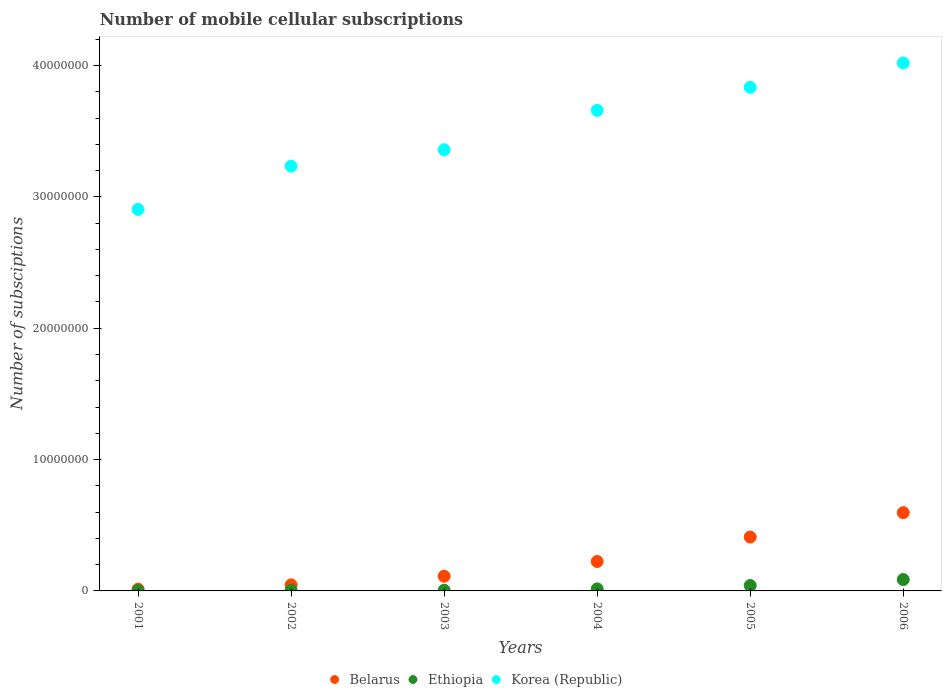Is the number of dotlines equal to the number of legend labels?
Your answer should be very brief. Yes. What is the number of mobile cellular subscriptions in Ethiopia in 2002?
Offer a terse response. 5.04e+04. Across all years, what is the maximum number of mobile cellular subscriptions in Korea (Republic)?
Provide a succinct answer. 4.02e+07. Across all years, what is the minimum number of mobile cellular subscriptions in Ethiopia?
Make the answer very short. 2.75e+04. In which year was the number of mobile cellular subscriptions in Ethiopia maximum?
Offer a terse response. 2006. In which year was the number of mobile cellular subscriptions in Korea (Republic) minimum?
Your response must be concise. 2001. What is the total number of mobile cellular subscriptions in Ethiopia in the graph?
Provide a succinct answer. 1.56e+06. What is the difference between the number of mobile cellular subscriptions in Belarus in 2003 and that in 2005?
Offer a very short reply. -2.98e+06. What is the difference between the number of mobile cellular subscriptions in Belarus in 2003 and the number of mobile cellular subscriptions in Korea (Republic) in 2001?
Offer a terse response. -2.79e+07. What is the average number of mobile cellular subscriptions in Korea (Republic) per year?
Offer a very short reply. 3.50e+07. In the year 2002, what is the difference between the number of mobile cellular subscriptions in Korea (Republic) and number of mobile cellular subscriptions in Belarus?
Give a very brief answer. 3.19e+07. What is the ratio of the number of mobile cellular subscriptions in Ethiopia in 2004 to that in 2006?
Keep it short and to the point. 0.18. Is the number of mobile cellular subscriptions in Korea (Republic) in 2001 less than that in 2006?
Your response must be concise. Yes. Is the difference between the number of mobile cellular subscriptions in Korea (Republic) in 2003 and 2005 greater than the difference between the number of mobile cellular subscriptions in Belarus in 2003 and 2005?
Offer a very short reply. No. What is the difference between the highest and the second highest number of mobile cellular subscriptions in Korea (Republic)?
Give a very brief answer. 1.85e+06. What is the difference between the highest and the lowest number of mobile cellular subscriptions in Ethiopia?
Make the answer very short. 8.39e+05. In how many years, is the number of mobile cellular subscriptions in Ethiopia greater than the average number of mobile cellular subscriptions in Ethiopia taken over all years?
Keep it short and to the point. 2. Is the sum of the number of mobile cellular subscriptions in Korea (Republic) in 2001 and 2002 greater than the maximum number of mobile cellular subscriptions in Belarus across all years?
Ensure brevity in your answer.  Yes. Does the number of mobile cellular subscriptions in Korea (Republic) monotonically increase over the years?
Keep it short and to the point. Yes. How many dotlines are there?
Offer a very short reply. 3. How many years are there in the graph?
Provide a succinct answer. 6. Are the values on the major ticks of Y-axis written in scientific E-notation?
Provide a succinct answer. No. Does the graph contain any zero values?
Make the answer very short. No. Does the graph contain grids?
Give a very brief answer. No. How many legend labels are there?
Offer a terse response. 3. How are the legend labels stacked?
Keep it short and to the point. Horizontal. What is the title of the graph?
Provide a succinct answer. Number of mobile cellular subscriptions. Does "Sint Maarten (Dutch part)" appear as one of the legend labels in the graph?
Provide a succinct answer. No. What is the label or title of the Y-axis?
Offer a terse response. Number of subsciptions. What is the Number of subsciptions in Belarus in 2001?
Ensure brevity in your answer.  1.38e+05. What is the Number of subsciptions of Ethiopia in 2001?
Make the answer very short. 2.75e+04. What is the Number of subsciptions in Korea (Republic) in 2001?
Provide a succinct answer. 2.90e+07. What is the Number of subsciptions of Belarus in 2002?
Make the answer very short. 4.63e+05. What is the Number of subsciptions of Ethiopia in 2002?
Your response must be concise. 5.04e+04. What is the Number of subsciptions in Korea (Republic) in 2002?
Your answer should be compact. 3.23e+07. What is the Number of subsciptions in Belarus in 2003?
Provide a short and direct response. 1.12e+06. What is the Number of subsciptions in Ethiopia in 2003?
Your answer should be very brief. 5.13e+04. What is the Number of subsciptions in Korea (Republic) in 2003?
Offer a terse response. 3.36e+07. What is the Number of subsciptions of Belarus in 2004?
Your answer should be compact. 2.24e+06. What is the Number of subsciptions in Ethiopia in 2004?
Make the answer very short. 1.56e+05. What is the Number of subsciptions of Korea (Republic) in 2004?
Your answer should be very brief. 3.66e+07. What is the Number of subsciptions of Belarus in 2005?
Your response must be concise. 4.10e+06. What is the Number of subsciptions of Ethiopia in 2005?
Provide a succinct answer. 4.11e+05. What is the Number of subsciptions of Korea (Republic) in 2005?
Offer a terse response. 3.83e+07. What is the Number of subsciptions in Belarus in 2006?
Offer a very short reply. 5.96e+06. What is the Number of subsciptions in Ethiopia in 2006?
Offer a very short reply. 8.67e+05. What is the Number of subsciptions of Korea (Republic) in 2006?
Make the answer very short. 4.02e+07. Across all years, what is the maximum Number of subsciptions of Belarus?
Keep it short and to the point. 5.96e+06. Across all years, what is the maximum Number of subsciptions of Ethiopia?
Make the answer very short. 8.67e+05. Across all years, what is the maximum Number of subsciptions of Korea (Republic)?
Ensure brevity in your answer.  4.02e+07. Across all years, what is the minimum Number of subsciptions in Belarus?
Make the answer very short. 1.38e+05. Across all years, what is the minimum Number of subsciptions of Ethiopia?
Offer a terse response. 2.75e+04. Across all years, what is the minimum Number of subsciptions in Korea (Republic)?
Make the answer very short. 2.90e+07. What is the total Number of subsciptions of Belarus in the graph?
Offer a terse response. 1.40e+07. What is the total Number of subsciptions in Ethiopia in the graph?
Offer a terse response. 1.56e+06. What is the total Number of subsciptions in Korea (Republic) in the graph?
Offer a very short reply. 2.10e+08. What is the difference between the Number of subsciptions in Belarus in 2001 and that in 2002?
Ensure brevity in your answer.  -3.24e+05. What is the difference between the Number of subsciptions in Ethiopia in 2001 and that in 2002?
Your response must be concise. -2.29e+04. What is the difference between the Number of subsciptions in Korea (Republic) in 2001 and that in 2002?
Ensure brevity in your answer.  -3.30e+06. What is the difference between the Number of subsciptions of Belarus in 2001 and that in 2003?
Provide a short and direct response. -9.80e+05. What is the difference between the Number of subsciptions in Ethiopia in 2001 and that in 2003?
Offer a very short reply. -2.38e+04. What is the difference between the Number of subsciptions of Korea (Republic) in 2001 and that in 2003?
Provide a succinct answer. -4.55e+06. What is the difference between the Number of subsciptions of Belarus in 2001 and that in 2004?
Your answer should be very brief. -2.10e+06. What is the difference between the Number of subsciptions of Ethiopia in 2001 and that in 2004?
Your answer should be very brief. -1.28e+05. What is the difference between the Number of subsciptions of Korea (Republic) in 2001 and that in 2004?
Your response must be concise. -7.54e+06. What is the difference between the Number of subsciptions of Belarus in 2001 and that in 2005?
Your answer should be very brief. -3.96e+06. What is the difference between the Number of subsciptions in Ethiopia in 2001 and that in 2005?
Provide a short and direct response. -3.83e+05. What is the difference between the Number of subsciptions in Korea (Republic) in 2001 and that in 2005?
Keep it short and to the point. -9.30e+06. What is the difference between the Number of subsciptions of Belarus in 2001 and that in 2006?
Provide a succinct answer. -5.82e+06. What is the difference between the Number of subsciptions of Ethiopia in 2001 and that in 2006?
Provide a succinct answer. -8.39e+05. What is the difference between the Number of subsciptions in Korea (Republic) in 2001 and that in 2006?
Ensure brevity in your answer.  -1.12e+07. What is the difference between the Number of subsciptions of Belarus in 2002 and that in 2003?
Offer a very short reply. -6.55e+05. What is the difference between the Number of subsciptions of Ethiopia in 2002 and that in 2003?
Provide a short and direct response. -955. What is the difference between the Number of subsciptions of Korea (Republic) in 2002 and that in 2003?
Your response must be concise. -1.25e+06. What is the difference between the Number of subsciptions of Belarus in 2002 and that in 2004?
Your answer should be compact. -1.78e+06. What is the difference between the Number of subsciptions of Ethiopia in 2002 and that in 2004?
Keep it short and to the point. -1.05e+05. What is the difference between the Number of subsciptions of Korea (Republic) in 2002 and that in 2004?
Provide a succinct answer. -4.24e+06. What is the difference between the Number of subsciptions of Belarus in 2002 and that in 2005?
Offer a very short reply. -3.64e+06. What is the difference between the Number of subsciptions of Ethiopia in 2002 and that in 2005?
Your answer should be very brief. -3.60e+05. What is the difference between the Number of subsciptions of Korea (Republic) in 2002 and that in 2005?
Offer a very short reply. -6.00e+06. What is the difference between the Number of subsciptions in Belarus in 2002 and that in 2006?
Your response must be concise. -5.50e+06. What is the difference between the Number of subsciptions of Ethiopia in 2002 and that in 2006?
Your answer should be compact. -8.16e+05. What is the difference between the Number of subsciptions of Korea (Republic) in 2002 and that in 2006?
Provide a succinct answer. -7.85e+06. What is the difference between the Number of subsciptions of Belarus in 2003 and that in 2004?
Your response must be concise. -1.12e+06. What is the difference between the Number of subsciptions in Ethiopia in 2003 and that in 2004?
Your answer should be compact. -1.04e+05. What is the difference between the Number of subsciptions in Korea (Republic) in 2003 and that in 2004?
Keep it short and to the point. -2.99e+06. What is the difference between the Number of subsciptions of Belarus in 2003 and that in 2005?
Your response must be concise. -2.98e+06. What is the difference between the Number of subsciptions of Ethiopia in 2003 and that in 2005?
Provide a short and direct response. -3.59e+05. What is the difference between the Number of subsciptions of Korea (Republic) in 2003 and that in 2005?
Your answer should be compact. -4.75e+06. What is the difference between the Number of subsciptions of Belarus in 2003 and that in 2006?
Keep it short and to the point. -4.84e+06. What is the difference between the Number of subsciptions of Ethiopia in 2003 and that in 2006?
Ensure brevity in your answer.  -8.15e+05. What is the difference between the Number of subsciptions of Korea (Republic) in 2003 and that in 2006?
Keep it short and to the point. -6.61e+06. What is the difference between the Number of subsciptions in Belarus in 2004 and that in 2005?
Your answer should be compact. -1.86e+06. What is the difference between the Number of subsciptions in Ethiopia in 2004 and that in 2005?
Make the answer very short. -2.55e+05. What is the difference between the Number of subsciptions of Korea (Republic) in 2004 and that in 2005?
Make the answer very short. -1.76e+06. What is the difference between the Number of subsciptions in Belarus in 2004 and that in 2006?
Your answer should be compact. -3.72e+06. What is the difference between the Number of subsciptions in Ethiopia in 2004 and that in 2006?
Provide a succinct answer. -7.11e+05. What is the difference between the Number of subsciptions in Korea (Republic) in 2004 and that in 2006?
Provide a short and direct response. -3.61e+06. What is the difference between the Number of subsciptions of Belarus in 2005 and that in 2006?
Your answer should be compact. -1.86e+06. What is the difference between the Number of subsciptions of Ethiopia in 2005 and that in 2006?
Your answer should be very brief. -4.56e+05. What is the difference between the Number of subsciptions in Korea (Republic) in 2005 and that in 2006?
Your answer should be very brief. -1.85e+06. What is the difference between the Number of subsciptions of Belarus in 2001 and the Number of subsciptions of Ethiopia in 2002?
Your answer should be compact. 8.80e+04. What is the difference between the Number of subsciptions in Belarus in 2001 and the Number of subsciptions in Korea (Republic) in 2002?
Your response must be concise. -3.22e+07. What is the difference between the Number of subsciptions in Ethiopia in 2001 and the Number of subsciptions in Korea (Republic) in 2002?
Make the answer very short. -3.23e+07. What is the difference between the Number of subsciptions of Belarus in 2001 and the Number of subsciptions of Ethiopia in 2003?
Offer a terse response. 8.70e+04. What is the difference between the Number of subsciptions of Belarus in 2001 and the Number of subsciptions of Korea (Republic) in 2003?
Make the answer very short. -3.35e+07. What is the difference between the Number of subsciptions of Ethiopia in 2001 and the Number of subsciptions of Korea (Republic) in 2003?
Keep it short and to the point. -3.36e+07. What is the difference between the Number of subsciptions of Belarus in 2001 and the Number of subsciptions of Ethiopia in 2004?
Ensure brevity in your answer.  -1.72e+04. What is the difference between the Number of subsciptions in Belarus in 2001 and the Number of subsciptions in Korea (Republic) in 2004?
Provide a short and direct response. -3.64e+07. What is the difference between the Number of subsciptions of Ethiopia in 2001 and the Number of subsciptions of Korea (Republic) in 2004?
Your response must be concise. -3.66e+07. What is the difference between the Number of subsciptions of Belarus in 2001 and the Number of subsciptions of Ethiopia in 2005?
Provide a short and direct response. -2.72e+05. What is the difference between the Number of subsciptions in Belarus in 2001 and the Number of subsciptions in Korea (Republic) in 2005?
Make the answer very short. -3.82e+07. What is the difference between the Number of subsciptions in Ethiopia in 2001 and the Number of subsciptions in Korea (Republic) in 2005?
Keep it short and to the point. -3.83e+07. What is the difference between the Number of subsciptions of Belarus in 2001 and the Number of subsciptions of Ethiopia in 2006?
Make the answer very short. -7.28e+05. What is the difference between the Number of subsciptions of Belarus in 2001 and the Number of subsciptions of Korea (Republic) in 2006?
Offer a terse response. -4.01e+07. What is the difference between the Number of subsciptions of Ethiopia in 2001 and the Number of subsciptions of Korea (Republic) in 2006?
Make the answer very short. -4.02e+07. What is the difference between the Number of subsciptions in Belarus in 2002 and the Number of subsciptions in Ethiopia in 2003?
Offer a terse response. 4.11e+05. What is the difference between the Number of subsciptions of Belarus in 2002 and the Number of subsciptions of Korea (Republic) in 2003?
Offer a very short reply. -3.31e+07. What is the difference between the Number of subsciptions in Ethiopia in 2002 and the Number of subsciptions in Korea (Republic) in 2003?
Your answer should be very brief. -3.35e+07. What is the difference between the Number of subsciptions of Belarus in 2002 and the Number of subsciptions of Ethiopia in 2004?
Your answer should be compact. 3.07e+05. What is the difference between the Number of subsciptions of Belarus in 2002 and the Number of subsciptions of Korea (Republic) in 2004?
Give a very brief answer. -3.61e+07. What is the difference between the Number of subsciptions in Ethiopia in 2002 and the Number of subsciptions in Korea (Republic) in 2004?
Give a very brief answer. -3.65e+07. What is the difference between the Number of subsciptions of Belarus in 2002 and the Number of subsciptions of Ethiopia in 2005?
Offer a terse response. 5.20e+04. What is the difference between the Number of subsciptions in Belarus in 2002 and the Number of subsciptions in Korea (Republic) in 2005?
Your response must be concise. -3.79e+07. What is the difference between the Number of subsciptions of Ethiopia in 2002 and the Number of subsciptions of Korea (Republic) in 2005?
Offer a terse response. -3.83e+07. What is the difference between the Number of subsciptions in Belarus in 2002 and the Number of subsciptions in Ethiopia in 2006?
Provide a short and direct response. -4.04e+05. What is the difference between the Number of subsciptions of Belarus in 2002 and the Number of subsciptions of Korea (Republic) in 2006?
Offer a very short reply. -3.97e+07. What is the difference between the Number of subsciptions of Ethiopia in 2002 and the Number of subsciptions of Korea (Republic) in 2006?
Offer a very short reply. -4.01e+07. What is the difference between the Number of subsciptions of Belarus in 2003 and the Number of subsciptions of Ethiopia in 2004?
Your answer should be compact. 9.62e+05. What is the difference between the Number of subsciptions of Belarus in 2003 and the Number of subsciptions of Korea (Republic) in 2004?
Offer a very short reply. -3.55e+07. What is the difference between the Number of subsciptions of Ethiopia in 2003 and the Number of subsciptions of Korea (Republic) in 2004?
Ensure brevity in your answer.  -3.65e+07. What is the difference between the Number of subsciptions in Belarus in 2003 and the Number of subsciptions in Ethiopia in 2005?
Make the answer very short. 7.07e+05. What is the difference between the Number of subsciptions of Belarus in 2003 and the Number of subsciptions of Korea (Republic) in 2005?
Give a very brief answer. -3.72e+07. What is the difference between the Number of subsciptions in Ethiopia in 2003 and the Number of subsciptions in Korea (Republic) in 2005?
Make the answer very short. -3.83e+07. What is the difference between the Number of subsciptions in Belarus in 2003 and the Number of subsciptions in Ethiopia in 2006?
Your response must be concise. 2.51e+05. What is the difference between the Number of subsciptions of Belarus in 2003 and the Number of subsciptions of Korea (Republic) in 2006?
Provide a short and direct response. -3.91e+07. What is the difference between the Number of subsciptions of Ethiopia in 2003 and the Number of subsciptions of Korea (Republic) in 2006?
Offer a very short reply. -4.01e+07. What is the difference between the Number of subsciptions in Belarus in 2004 and the Number of subsciptions in Ethiopia in 2005?
Make the answer very short. 1.83e+06. What is the difference between the Number of subsciptions of Belarus in 2004 and the Number of subsciptions of Korea (Republic) in 2005?
Keep it short and to the point. -3.61e+07. What is the difference between the Number of subsciptions in Ethiopia in 2004 and the Number of subsciptions in Korea (Republic) in 2005?
Keep it short and to the point. -3.82e+07. What is the difference between the Number of subsciptions of Belarus in 2004 and the Number of subsciptions of Ethiopia in 2006?
Offer a terse response. 1.37e+06. What is the difference between the Number of subsciptions in Belarus in 2004 and the Number of subsciptions in Korea (Republic) in 2006?
Offer a very short reply. -3.80e+07. What is the difference between the Number of subsciptions of Ethiopia in 2004 and the Number of subsciptions of Korea (Republic) in 2006?
Your answer should be compact. -4.00e+07. What is the difference between the Number of subsciptions of Belarus in 2005 and the Number of subsciptions of Ethiopia in 2006?
Give a very brief answer. 3.23e+06. What is the difference between the Number of subsciptions of Belarus in 2005 and the Number of subsciptions of Korea (Republic) in 2006?
Give a very brief answer. -3.61e+07. What is the difference between the Number of subsciptions of Ethiopia in 2005 and the Number of subsciptions of Korea (Republic) in 2006?
Your answer should be compact. -3.98e+07. What is the average Number of subsciptions of Belarus per year?
Offer a very short reply. 2.34e+06. What is the average Number of subsciptions in Ethiopia per year?
Provide a succinct answer. 2.60e+05. What is the average Number of subsciptions of Korea (Republic) per year?
Offer a very short reply. 3.50e+07. In the year 2001, what is the difference between the Number of subsciptions of Belarus and Number of subsciptions of Ethiopia?
Offer a very short reply. 1.11e+05. In the year 2001, what is the difference between the Number of subsciptions in Belarus and Number of subsciptions in Korea (Republic)?
Offer a terse response. -2.89e+07. In the year 2001, what is the difference between the Number of subsciptions in Ethiopia and Number of subsciptions in Korea (Republic)?
Provide a short and direct response. -2.90e+07. In the year 2002, what is the difference between the Number of subsciptions of Belarus and Number of subsciptions of Ethiopia?
Offer a terse response. 4.12e+05. In the year 2002, what is the difference between the Number of subsciptions in Belarus and Number of subsciptions in Korea (Republic)?
Your response must be concise. -3.19e+07. In the year 2002, what is the difference between the Number of subsciptions of Ethiopia and Number of subsciptions of Korea (Republic)?
Give a very brief answer. -3.23e+07. In the year 2003, what is the difference between the Number of subsciptions in Belarus and Number of subsciptions in Ethiopia?
Provide a short and direct response. 1.07e+06. In the year 2003, what is the difference between the Number of subsciptions in Belarus and Number of subsciptions in Korea (Republic)?
Make the answer very short. -3.25e+07. In the year 2003, what is the difference between the Number of subsciptions in Ethiopia and Number of subsciptions in Korea (Republic)?
Make the answer very short. -3.35e+07. In the year 2004, what is the difference between the Number of subsciptions in Belarus and Number of subsciptions in Ethiopia?
Your answer should be very brief. 2.08e+06. In the year 2004, what is the difference between the Number of subsciptions of Belarus and Number of subsciptions of Korea (Republic)?
Provide a succinct answer. -3.43e+07. In the year 2004, what is the difference between the Number of subsciptions of Ethiopia and Number of subsciptions of Korea (Republic)?
Give a very brief answer. -3.64e+07. In the year 2005, what is the difference between the Number of subsciptions of Belarus and Number of subsciptions of Ethiopia?
Your answer should be compact. 3.69e+06. In the year 2005, what is the difference between the Number of subsciptions in Belarus and Number of subsciptions in Korea (Republic)?
Provide a short and direct response. -3.42e+07. In the year 2005, what is the difference between the Number of subsciptions of Ethiopia and Number of subsciptions of Korea (Republic)?
Offer a very short reply. -3.79e+07. In the year 2006, what is the difference between the Number of subsciptions in Belarus and Number of subsciptions in Ethiopia?
Give a very brief answer. 5.09e+06. In the year 2006, what is the difference between the Number of subsciptions in Belarus and Number of subsciptions in Korea (Republic)?
Your response must be concise. -3.42e+07. In the year 2006, what is the difference between the Number of subsciptions of Ethiopia and Number of subsciptions of Korea (Republic)?
Provide a succinct answer. -3.93e+07. What is the ratio of the Number of subsciptions in Belarus in 2001 to that in 2002?
Provide a succinct answer. 0.3. What is the ratio of the Number of subsciptions of Ethiopia in 2001 to that in 2002?
Provide a succinct answer. 0.55. What is the ratio of the Number of subsciptions of Korea (Republic) in 2001 to that in 2002?
Your answer should be compact. 0.9. What is the ratio of the Number of subsciptions in Belarus in 2001 to that in 2003?
Your response must be concise. 0.12. What is the ratio of the Number of subsciptions of Ethiopia in 2001 to that in 2003?
Make the answer very short. 0.54. What is the ratio of the Number of subsciptions of Korea (Republic) in 2001 to that in 2003?
Offer a very short reply. 0.86. What is the ratio of the Number of subsciptions in Belarus in 2001 to that in 2004?
Keep it short and to the point. 0.06. What is the ratio of the Number of subsciptions in Ethiopia in 2001 to that in 2004?
Give a very brief answer. 0.18. What is the ratio of the Number of subsciptions in Korea (Republic) in 2001 to that in 2004?
Provide a short and direct response. 0.79. What is the ratio of the Number of subsciptions of Belarus in 2001 to that in 2005?
Give a very brief answer. 0.03. What is the ratio of the Number of subsciptions in Ethiopia in 2001 to that in 2005?
Offer a terse response. 0.07. What is the ratio of the Number of subsciptions of Korea (Republic) in 2001 to that in 2005?
Provide a succinct answer. 0.76. What is the ratio of the Number of subsciptions of Belarus in 2001 to that in 2006?
Your response must be concise. 0.02. What is the ratio of the Number of subsciptions of Ethiopia in 2001 to that in 2006?
Offer a very short reply. 0.03. What is the ratio of the Number of subsciptions of Korea (Republic) in 2001 to that in 2006?
Give a very brief answer. 0.72. What is the ratio of the Number of subsciptions of Belarus in 2002 to that in 2003?
Offer a terse response. 0.41. What is the ratio of the Number of subsciptions in Ethiopia in 2002 to that in 2003?
Offer a very short reply. 0.98. What is the ratio of the Number of subsciptions of Korea (Republic) in 2002 to that in 2003?
Ensure brevity in your answer.  0.96. What is the ratio of the Number of subsciptions of Belarus in 2002 to that in 2004?
Your answer should be compact. 0.21. What is the ratio of the Number of subsciptions in Ethiopia in 2002 to that in 2004?
Give a very brief answer. 0.32. What is the ratio of the Number of subsciptions in Korea (Republic) in 2002 to that in 2004?
Your answer should be very brief. 0.88. What is the ratio of the Number of subsciptions of Belarus in 2002 to that in 2005?
Your answer should be very brief. 0.11. What is the ratio of the Number of subsciptions of Ethiopia in 2002 to that in 2005?
Offer a terse response. 0.12. What is the ratio of the Number of subsciptions of Korea (Republic) in 2002 to that in 2005?
Your answer should be very brief. 0.84. What is the ratio of the Number of subsciptions in Belarus in 2002 to that in 2006?
Provide a succinct answer. 0.08. What is the ratio of the Number of subsciptions of Ethiopia in 2002 to that in 2006?
Your answer should be compact. 0.06. What is the ratio of the Number of subsciptions of Korea (Republic) in 2002 to that in 2006?
Provide a short and direct response. 0.8. What is the ratio of the Number of subsciptions of Belarus in 2003 to that in 2004?
Your answer should be very brief. 0.5. What is the ratio of the Number of subsciptions in Ethiopia in 2003 to that in 2004?
Your answer should be very brief. 0.33. What is the ratio of the Number of subsciptions in Korea (Republic) in 2003 to that in 2004?
Give a very brief answer. 0.92. What is the ratio of the Number of subsciptions of Belarus in 2003 to that in 2005?
Keep it short and to the point. 0.27. What is the ratio of the Number of subsciptions in Korea (Republic) in 2003 to that in 2005?
Offer a terse response. 0.88. What is the ratio of the Number of subsciptions in Belarus in 2003 to that in 2006?
Offer a terse response. 0.19. What is the ratio of the Number of subsciptions in Ethiopia in 2003 to that in 2006?
Keep it short and to the point. 0.06. What is the ratio of the Number of subsciptions in Korea (Republic) in 2003 to that in 2006?
Provide a short and direct response. 0.84. What is the ratio of the Number of subsciptions in Belarus in 2004 to that in 2005?
Your answer should be compact. 0.55. What is the ratio of the Number of subsciptions of Ethiopia in 2004 to that in 2005?
Keep it short and to the point. 0.38. What is the ratio of the Number of subsciptions of Korea (Republic) in 2004 to that in 2005?
Give a very brief answer. 0.95. What is the ratio of the Number of subsciptions in Belarus in 2004 to that in 2006?
Offer a terse response. 0.38. What is the ratio of the Number of subsciptions of Ethiopia in 2004 to that in 2006?
Your answer should be very brief. 0.18. What is the ratio of the Number of subsciptions in Korea (Republic) in 2004 to that in 2006?
Your answer should be very brief. 0.91. What is the ratio of the Number of subsciptions in Belarus in 2005 to that in 2006?
Provide a succinct answer. 0.69. What is the ratio of the Number of subsciptions in Ethiopia in 2005 to that in 2006?
Make the answer very short. 0.47. What is the ratio of the Number of subsciptions in Korea (Republic) in 2005 to that in 2006?
Your answer should be very brief. 0.95. What is the difference between the highest and the second highest Number of subsciptions of Belarus?
Your answer should be compact. 1.86e+06. What is the difference between the highest and the second highest Number of subsciptions of Ethiopia?
Your answer should be compact. 4.56e+05. What is the difference between the highest and the second highest Number of subsciptions of Korea (Republic)?
Make the answer very short. 1.85e+06. What is the difference between the highest and the lowest Number of subsciptions of Belarus?
Your answer should be very brief. 5.82e+06. What is the difference between the highest and the lowest Number of subsciptions of Ethiopia?
Provide a short and direct response. 8.39e+05. What is the difference between the highest and the lowest Number of subsciptions in Korea (Republic)?
Provide a short and direct response. 1.12e+07. 